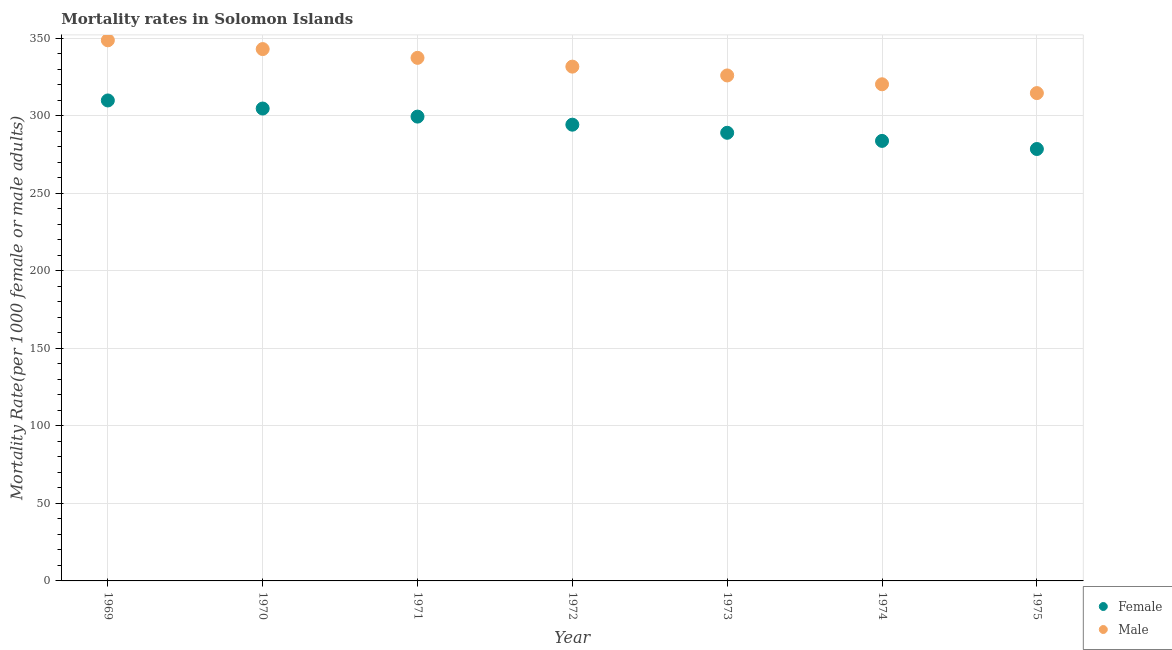How many different coloured dotlines are there?
Provide a short and direct response. 2. What is the male mortality rate in 1969?
Provide a short and direct response. 348.65. Across all years, what is the maximum male mortality rate?
Offer a terse response. 348.65. Across all years, what is the minimum male mortality rate?
Your response must be concise. 314.61. In which year was the male mortality rate maximum?
Your response must be concise. 1969. In which year was the male mortality rate minimum?
Keep it short and to the point. 1975. What is the total male mortality rate in the graph?
Your answer should be very brief. 2321.57. What is the difference between the male mortality rate in 1971 and that in 1975?
Keep it short and to the point. 22.73. What is the difference between the male mortality rate in 1972 and the female mortality rate in 1971?
Make the answer very short. 32.23. What is the average male mortality rate per year?
Offer a terse response. 331.65. In the year 1972, what is the difference between the male mortality rate and female mortality rate?
Offer a terse response. 37.44. In how many years, is the female mortality rate greater than 100?
Your response must be concise. 7. What is the ratio of the male mortality rate in 1969 to that in 1971?
Give a very brief answer. 1.03. Is the male mortality rate in 1970 less than that in 1974?
Give a very brief answer. No. Is the difference between the female mortality rate in 1969 and 1974 greater than the difference between the male mortality rate in 1969 and 1974?
Provide a short and direct response. No. What is the difference between the highest and the second highest male mortality rate?
Make the answer very short. 5.66. What is the difference between the highest and the lowest male mortality rate?
Ensure brevity in your answer.  34.05. In how many years, is the male mortality rate greater than the average male mortality rate taken over all years?
Provide a short and direct response. 4. Does the male mortality rate monotonically increase over the years?
Give a very brief answer. No. Is the female mortality rate strictly greater than the male mortality rate over the years?
Offer a very short reply. No. How many dotlines are there?
Keep it short and to the point. 2. How many years are there in the graph?
Provide a short and direct response. 7. Does the graph contain any zero values?
Make the answer very short. No. Does the graph contain grids?
Offer a very short reply. Yes. What is the title of the graph?
Make the answer very short. Mortality rates in Solomon Islands. What is the label or title of the X-axis?
Offer a very short reply. Year. What is the label or title of the Y-axis?
Ensure brevity in your answer.  Mortality Rate(per 1000 female or male adults). What is the Mortality Rate(per 1000 female or male adults) of Female in 1969?
Make the answer very short. 309.86. What is the Mortality Rate(per 1000 female or male adults) in Male in 1969?
Your response must be concise. 348.65. What is the Mortality Rate(per 1000 female or male adults) in Female in 1970?
Your answer should be compact. 304.66. What is the Mortality Rate(per 1000 female or male adults) in Male in 1970?
Offer a terse response. 343. What is the Mortality Rate(per 1000 female or male adults) of Female in 1971?
Your response must be concise. 299.45. What is the Mortality Rate(per 1000 female or male adults) of Male in 1971?
Your answer should be very brief. 337.34. What is the Mortality Rate(per 1000 female or male adults) in Female in 1972?
Your answer should be very brief. 294.24. What is the Mortality Rate(per 1000 female or male adults) of Male in 1972?
Provide a short and direct response. 331.68. What is the Mortality Rate(per 1000 female or male adults) in Female in 1973?
Make the answer very short. 289.01. What is the Mortality Rate(per 1000 female or male adults) in Male in 1973?
Provide a short and direct response. 325.99. What is the Mortality Rate(per 1000 female or male adults) of Female in 1974?
Make the answer very short. 283.78. What is the Mortality Rate(per 1000 female or male adults) of Male in 1974?
Your response must be concise. 320.3. What is the Mortality Rate(per 1000 female or male adults) in Female in 1975?
Your response must be concise. 278.56. What is the Mortality Rate(per 1000 female or male adults) in Male in 1975?
Offer a terse response. 314.61. Across all years, what is the maximum Mortality Rate(per 1000 female or male adults) of Female?
Provide a short and direct response. 309.86. Across all years, what is the maximum Mortality Rate(per 1000 female or male adults) of Male?
Give a very brief answer. 348.65. Across all years, what is the minimum Mortality Rate(per 1000 female or male adults) in Female?
Your answer should be very brief. 278.56. Across all years, what is the minimum Mortality Rate(per 1000 female or male adults) of Male?
Provide a short and direct response. 314.61. What is the total Mortality Rate(per 1000 female or male adults) of Female in the graph?
Ensure brevity in your answer.  2059.56. What is the total Mortality Rate(per 1000 female or male adults) in Male in the graph?
Provide a short and direct response. 2321.57. What is the difference between the Mortality Rate(per 1000 female or male adults) in Female in 1969 and that in 1970?
Offer a terse response. 5.21. What is the difference between the Mortality Rate(per 1000 female or male adults) in Male in 1969 and that in 1970?
Keep it short and to the point. 5.66. What is the difference between the Mortality Rate(per 1000 female or male adults) of Female in 1969 and that in 1971?
Offer a very short reply. 10.41. What is the difference between the Mortality Rate(per 1000 female or male adults) of Male in 1969 and that in 1971?
Offer a very short reply. 11.31. What is the difference between the Mortality Rate(per 1000 female or male adults) in Female in 1969 and that in 1972?
Your answer should be compact. 15.62. What is the difference between the Mortality Rate(per 1000 female or male adults) of Male in 1969 and that in 1972?
Make the answer very short. 16.97. What is the difference between the Mortality Rate(per 1000 female or male adults) in Female in 1969 and that in 1973?
Your response must be concise. 20.85. What is the difference between the Mortality Rate(per 1000 female or male adults) of Male in 1969 and that in 1973?
Make the answer very short. 22.66. What is the difference between the Mortality Rate(per 1000 female or male adults) in Female in 1969 and that in 1974?
Offer a very short reply. 26.08. What is the difference between the Mortality Rate(per 1000 female or male adults) of Male in 1969 and that in 1974?
Offer a terse response. 28.36. What is the difference between the Mortality Rate(per 1000 female or male adults) in Female in 1969 and that in 1975?
Provide a succinct answer. 31.31. What is the difference between the Mortality Rate(per 1000 female or male adults) of Male in 1969 and that in 1975?
Offer a very short reply. 34.05. What is the difference between the Mortality Rate(per 1000 female or male adults) in Female in 1970 and that in 1971?
Your response must be concise. 5.21. What is the difference between the Mortality Rate(per 1000 female or male adults) in Male in 1970 and that in 1971?
Your answer should be very brief. 5.66. What is the difference between the Mortality Rate(per 1000 female or male adults) in Female in 1970 and that in 1972?
Give a very brief answer. 10.41. What is the difference between the Mortality Rate(per 1000 female or male adults) in Male in 1970 and that in 1972?
Your answer should be compact. 11.31. What is the difference between the Mortality Rate(per 1000 female or male adults) of Female in 1970 and that in 1973?
Offer a very short reply. 15.64. What is the difference between the Mortality Rate(per 1000 female or male adults) of Male in 1970 and that in 1973?
Your response must be concise. 17.01. What is the difference between the Mortality Rate(per 1000 female or male adults) in Female in 1970 and that in 1974?
Offer a terse response. 20.87. What is the difference between the Mortality Rate(per 1000 female or male adults) of Male in 1970 and that in 1974?
Offer a very short reply. 22.7. What is the difference between the Mortality Rate(per 1000 female or male adults) in Female in 1970 and that in 1975?
Provide a succinct answer. 26.1. What is the difference between the Mortality Rate(per 1000 female or male adults) in Male in 1970 and that in 1975?
Provide a succinct answer. 28.39. What is the difference between the Mortality Rate(per 1000 female or male adults) of Female in 1971 and that in 1972?
Provide a succinct answer. 5.21. What is the difference between the Mortality Rate(per 1000 female or male adults) of Male in 1971 and that in 1972?
Provide a short and direct response. 5.66. What is the difference between the Mortality Rate(per 1000 female or male adults) of Female in 1971 and that in 1973?
Your response must be concise. 10.44. What is the difference between the Mortality Rate(per 1000 female or male adults) in Male in 1971 and that in 1973?
Give a very brief answer. 11.35. What is the difference between the Mortality Rate(per 1000 female or male adults) in Female in 1971 and that in 1974?
Keep it short and to the point. 15.66. What is the difference between the Mortality Rate(per 1000 female or male adults) of Male in 1971 and that in 1974?
Provide a short and direct response. 17.04. What is the difference between the Mortality Rate(per 1000 female or male adults) in Female in 1971 and that in 1975?
Your response must be concise. 20.89. What is the difference between the Mortality Rate(per 1000 female or male adults) of Male in 1971 and that in 1975?
Provide a succinct answer. 22.73. What is the difference between the Mortality Rate(per 1000 female or male adults) of Female in 1972 and that in 1973?
Your answer should be compact. 5.23. What is the difference between the Mortality Rate(per 1000 female or male adults) of Male in 1972 and that in 1973?
Offer a terse response. 5.69. What is the difference between the Mortality Rate(per 1000 female or male adults) in Female in 1972 and that in 1974?
Your answer should be compact. 10.46. What is the difference between the Mortality Rate(per 1000 female or male adults) in Male in 1972 and that in 1974?
Ensure brevity in your answer.  11.38. What is the difference between the Mortality Rate(per 1000 female or male adults) in Female in 1972 and that in 1975?
Make the answer very short. 15.69. What is the difference between the Mortality Rate(per 1000 female or male adults) of Male in 1972 and that in 1975?
Your answer should be compact. 17.07. What is the difference between the Mortality Rate(per 1000 female or male adults) in Female in 1973 and that in 1974?
Provide a succinct answer. 5.23. What is the difference between the Mortality Rate(per 1000 female or male adults) of Male in 1973 and that in 1974?
Offer a terse response. 5.69. What is the difference between the Mortality Rate(per 1000 female or male adults) of Female in 1973 and that in 1975?
Make the answer very short. 10.46. What is the difference between the Mortality Rate(per 1000 female or male adults) of Male in 1973 and that in 1975?
Your answer should be very brief. 11.38. What is the difference between the Mortality Rate(per 1000 female or male adults) in Female in 1974 and that in 1975?
Make the answer very short. 5.23. What is the difference between the Mortality Rate(per 1000 female or male adults) of Male in 1974 and that in 1975?
Your answer should be compact. 5.69. What is the difference between the Mortality Rate(per 1000 female or male adults) in Female in 1969 and the Mortality Rate(per 1000 female or male adults) in Male in 1970?
Provide a succinct answer. -33.13. What is the difference between the Mortality Rate(per 1000 female or male adults) in Female in 1969 and the Mortality Rate(per 1000 female or male adults) in Male in 1971?
Provide a short and direct response. -27.48. What is the difference between the Mortality Rate(per 1000 female or male adults) in Female in 1969 and the Mortality Rate(per 1000 female or male adults) in Male in 1972?
Make the answer very short. -21.82. What is the difference between the Mortality Rate(per 1000 female or male adults) of Female in 1969 and the Mortality Rate(per 1000 female or male adults) of Male in 1973?
Your response must be concise. -16.13. What is the difference between the Mortality Rate(per 1000 female or male adults) of Female in 1969 and the Mortality Rate(per 1000 female or male adults) of Male in 1974?
Keep it short and to the point. -10.44. What is the difference between the Mortality Rate(per 1000 female or male adults) in Female in 1969 and the Mortality Rate(per 1000 female or male adults) in Male in 1975?
Provide a succinct answer. -4.74. What is the difference between the Mortality Rate(per 1000 female or male adults) of Female in 1970 and the Mortality Rate(per 1000 female or male adults) of Male in 1971?
Ensure brevity in your answer.  -32.68. What is the difference between the Mortality Rate(per 1000 female or male adults) of Female in 1970 and the Mortality Rate(per 1000 female or male adults) of Male in 1972?
Provide a succinct answer. -27.03. What is the difference between the Mortality Rate(per 1000 female or male adults) in Female in 1970 and the Mortality Rate(per 1000 female or male adults) in Male in 1973?
Your answer should be compact. -21.33. What is the difference between the Mortality Rate(per 1000 female or male adults) in Female in 1970 and the Mortality Rate(per 1000 female or male adults) in Male in 1974?
Your answer should be very brief. -15.64. What is the difference between the Mortality Rate(per 1000 female or male adults) of Female in 1970 and the Mortality Rate(per 1000 female or male adults) of Male in 1975?
Provide a succinct answer. -9.95. What is the difference between the Mortality Rate(per 1000 female or male adults) in Female in 1971 and the Mortality Rate(per 1000 female or male adults) in Male in 1972?
Offer a very short reply. -32.23. What is the difference between the Mortality Rate(per 1000 female or male adults) of Female in 1971 and the Mortality Rate(per 1000 female or male adults) of Male in 1973?
Provide a short and direct response. -26.54. What is the difference between the Mortality Rate(per 1000 female or male adults) in Female in 1971 and the Mortality Rate(per 1000 female or male adults) in Male in 1974?
Provide a succinct answer. -20.85. What is the difference between the Mortality Rate(per 1000 female or male adults) in Female in 1971 and the Mortality Rate(per 1000 female or male adults) in Male in 1975?
Ensure brevity in your answer.  -15.16. What is the difference between the Mortality Rate(per 1000 female or male adults) of Female in 1972 and the Mortality Rate(per 1000 female or male adults) of Male in 1973?
Your response must be concise. -31.75. What is the difference between the Mortality Rate(per 1000 female or male adults) of Female in 1972 and the Mortality Rate(per 1000 female or male adults) of Male in 1974?
Make the answer very short. -26.06. What is the difference between the Mortality Rate(per 1000 female or male adults) in Female in 1972 and the Mortality Rate(per 1000 female or male adults) in Male in 1975?
Give a very brief answer. -20.37. What is the difference between the Mortality Rate(per 1000 female or male adults) of Female in 1973 and the Mortality Rate(per 1000 female or male adults) of Male in 1974?
Give a very brief answer. -31.29. What is the difference between the Mortality Rate(per 1000 female or male adults) of Female in 1973 and the Mortality Rate(per 1000 female or male adults) of Male in 1975?
Provide a succinct answer. -25.59. What is the difference between the Mortality Rate(per 1000 female or male adults) in Female in 1974 and the Mortality Rate(per 1000 female or male adults) in Male in 1975?
Your answer should be very brief. -30.82. What is the average Mortality Rate(per 1000 female or male adults) of Female per year?
Your answer should be compact. 294.22. What is the average Mortality Rate(per 1000 female or male adults) in Male per year?
Your answer should be very brief. 331.65. In the year 1969, what is the difference between the Mortality Rate(per 1000 female or male adults) in Female and Mortality Rate(per 1000 female or male adults) in Male?
Offer a terse response. -38.79. In the year 1970, what is the difference between the Mortality Rate(per 1000 female or male adults) of Female and Mortality Rate(per 1000 female or male adults) of Male?
Offer a terse response. -38.34. In the year 1971, what is the difference between the Mortality Rate(per 1000 female or male adults) in Female and Mortality Rate(per 1000 female or male adults) in Male?
Provide a succinct answer. -37.89. In the year 1972, what is the difference between the Mortality Rate(per 1000 female or male adults) of Female and Mortality Rate(per 1000 female or male adults) of Male?
Keep it short and to the point. -37.44. In the year 1973, what is the difference between the Mortality Rate(per 1000 female or male adults) in Female and Mortality Rate(per 1000 female or male adults) in Male?
Make the answer very short. -36.98. In the year 1974, what is the difference between the Mortality Rate(per 1000 female or male adults) in Female and Mortality Rate(per 1000 female or male adults) in Male?
Your response must be concise. -36.52. In the year 1975, what is the difference between the Mortality Rate(per 1000 female or male adults) of Female and Mortality Rate(per 1000 female or male adults) of Male?
Give a very brief answer. -36.05. What is the ratio of the Mortality Rate(per 1000 female or male adults) in Female in 1969 to that in 1970?
Provide a succinct answer. 1.02. What is the ratio of the Mortality Rate(per 1000 female or male adults) in Male in 1969 to that in 1970?
Offer a terse response. 1.02. What is the ratio of the Mortality Rate(per 1000 female or male adults) of Female in 1969 to that in 1971?
Offer a terse response. 1.03. What is the ratio of the Mortality Rate(per 1000 female or male adults) in Male in 1969 to that in 1971?
Your answer should be very brief. 1.03. What is the ratio of the Mortality Rate(per 1000 female or male adults) in Female in 1969 to that in 1972?
Keep it short and to the point. 1.05. What is the ratio of the Mortality Rate(per 1000 female or male adults) of Male in 1969 to that in 1972?
Your response must be concise. 1.05. What is the ratio of the Mortality Rate(per 1000 female or male adults) in Female in 1969 to that in 1973?
Keep it short and to the point. 1.07. What is the ratio of the Mortality Rate(per 1000 female or male adults) in Male in 1969 to that in 1973?
Provide a succinct answer. 1.07. What is the ratio of the Mortality Rate(per 1000 female or male adults) in Female in 1969 to that in 1974?
Your response must be concise. 1.09. What is the ratio of the Mortality Rate(per 1000 female or male adults) in Male in 1969 to that in 1974?
Make the answer very short. 1.09. What is the ratio of the Mortality Rate(per 1000 female or male adults) of Female in 1969 to that in 1975?
Your answer should be very brief. 1.11. What is the ratio of the Mortality Rate(per 1000 female or male adults) in Male in 1969 to that in 1975?
Your answer should be very brief. 1.11. What is the ratio of the Mortality Rate(per 1000 female or male adults) in Female in 1970 to that in 1971?
Keep it short and to the point. 1.02. What is the ratio of the Mortality Rate(per 1000 female or male adults) of Male in 1970 to that in 1971?
Your response must be concise. 1.02. What is the ratio of the Mortality Rate(per 1000 female or male adults) of Female in 1970 to that in 1972?
Offer a very short reply. 1.04. What is the ratio of the Mortality Rate(per 1000 female or male adults) of Male in 1970 to that in 1972?
Your answer should be compact. 1.03. What is the ratio of the Mortality Rate(per 1000 female or male adults) of Female in 1970 to that in 1973?
Give a very brief answer. 1.05. What is the ratio of the Mortality Rate(per 1000 female or male adults) in Male in 1970 to that in 1973?
Give a very brief answer. 1.05. What is the ratio of the Mortality Rate(per 1000 female or male adults) of Female in 1970 to that in 1974?
Keep it short and to the point. 1.07. What is the ratio of the Mortality Rate(per 1000 female or male adults) in Male in 1970 to that in 1974?
Offer a terse response. 1.07. What is the ratio of the Mortality Rate(per 1000 female or male adults) in Female in 1970 to that in 1975?
Your answer should be very brief. 1.09. What is the ratio of the Mortality Rate(per 1000 female or male adults) of Male in 1970 to that in 1975?
Offer a terse response. 1.09. What is the ratio of the Mortality Rate(per 1000 female or male adults) in Female in 1971 to that in 1972?
Provide a short and direct response. 1.02. What is the ratio of the Mortality Rate(per 1000 female or male adults) of Male in 1971 to that in 1972?
Make the answer very short. 1.02. What is the ratio of the Mortality Rate(per 1000 female or male adults) of Female in 1971 to that in 1973?
Make the answer very short. 1.04. What is the ratio of the Mortality Rate(per 1000 female or male adults) in Male in 1971 to that in 1973?
Provide a short and direct response. 1.03. What is the ratio of the Mortality Rate(per 1000 female or male adults) in Female in 1971 to that in 1974?
Offer a terse response. 1.06. What is the ratio of the Mortality Rate(per 1000 female or male adults) in Male in 1971 to that in 1974?
Provide a succinct answer. 1.05. What is the ratio of the Mortality Rate(per 1000 female or male adults) of Female in 1971 to that in 1975?
Give a very brief answer. 1.07. What is the ratio of the Mortality Rate(per 1000 female or male adults) in Male in 1971 to that in 1975?
Provide a short and direct response. 1.07. What is the ratio of the Mortality Rate(per 1000 female or male adults) of Female in 1972 to that in 1973?
Make the answer very short. 1.02. What is the ratio of the Mortality Rate(per 1000 female or male adults) in Male in 1972 to that in 1973?
Ensure brevity in your answer.  1.02. What is the ratio of the Mortality Rate(per 1000 female or male adults) of Female in 1972 to that in 1974?
Offer a terse response. 1.04. What is the ratio of the Mortality Rate(per 1000 female or male adults) of Male in 1972 to that in 1974?
Offer a very short reply. 1.04. What is the ratio of the Mortality Rate(per 1000 female or male adults) of Female in 1972 to that in 1975?
Your response must be concise. 1.06. What is the ratio of the Mortality Rate(per 1000 female or male adults) of Male in 1972 to that in 1975?
Your answer should be compact. 1.05. What is the ratio of the Mortality Rate(per 1000 female or male adults) in Female in 1973 to that in 1974?
Your answer should be very brief. 1.02. What is the ratio of the Mortality Rate(per 1000 female or male adults) of Male in 1973 to that in 1974?
Your response must be concise. 1.02. What is the ratio of the Mortality Rate(per 1000 female or male adults) of Female in 1973 to that in 1975?
Keep it short and to the point. 1.04. What is the ratio of the Mortality Rate(per 1000 female or male adults) of Male in 1973 to that in 1975?
Your response must be concise. 1.04. What is the ratio of the Mortality Rate(per 1000 female or male adults) of Female in 1974 to that in 1975?
Keep it short and to the point. 1.02. What is the ratio of the Mortality Rate(per 1000 female or male adults) in Male in 1974 to that in 1975?
Your response must be concise. 1.02. What is the difference between the highest and the second highest Mortality Rate(per 1000 female or male adults) of Female?
Provide a succinct answer. 5.21. What is the difference between the highest and the second highest Mortality Rate(per 1000 female or male adults) of Male?
Provide a short and direct response. 5.66. What is the difference between the highest and the lowest Mortality Rate(per 1000 female or male adults) in Female?
Offer a terse response. 31.31. What is the difference between the highest and the lowest Mortality Rate(per 1000 female or male adults) in Male?
Provide a short and direct response. 34.05. 